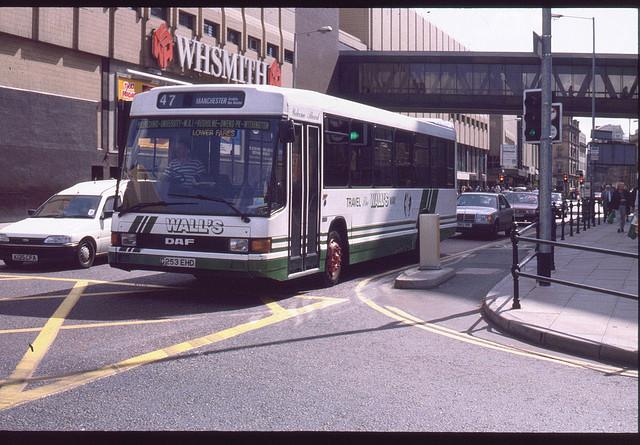Is the ground damp?
Quick response, please. No. Can you see the bus driver?
Write a very short answer. Yes. What number is on the front of the bus?
Write a very short answer. 47. What's written on the side of the building?
Write a very short answer. Whsmith. Is this vehicle a train?
Give a very brief answer. No. 